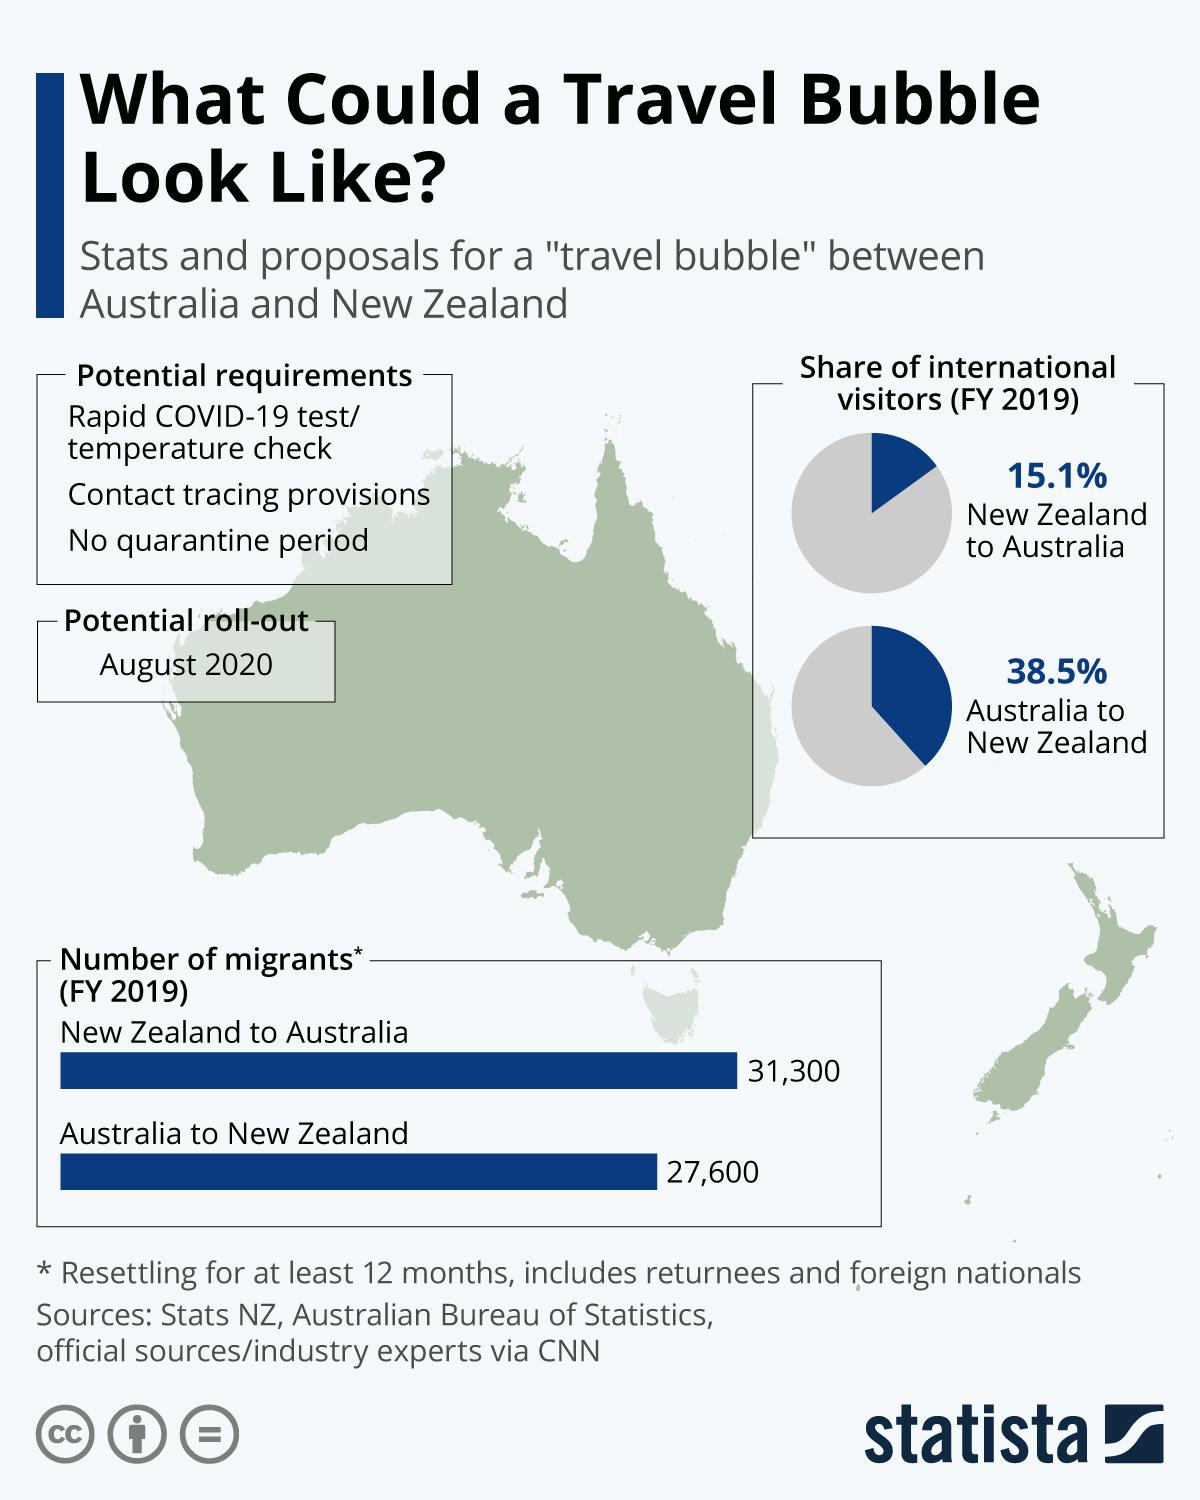Mention a couple of crucial points in this snapshot. In 2019, a greater number of individuals migrated from New Zealand to Australia than in previous years. The second most important requirement for travel is contact tracing provisions. The Travel Bubble Plan is likely to be introduced in August 2020. Potential requirements for travel, listed third, do not include a quarantine period. 